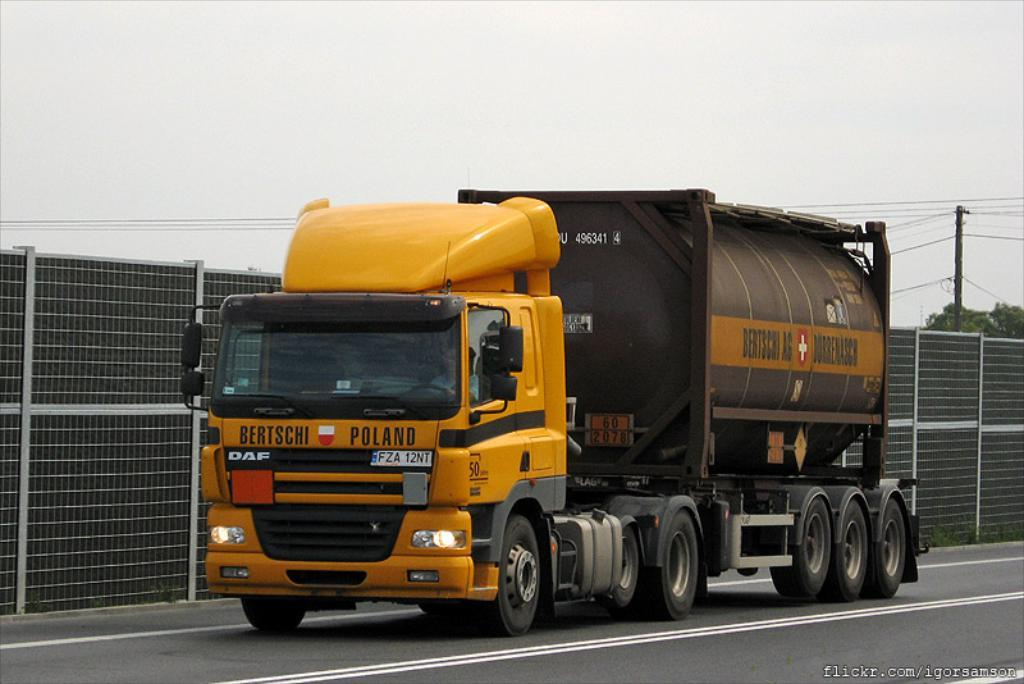What is on the road in the image? There is a vehicle on the road in the image. What can be seen near the road in the image? There is a fence in the image. What else is present in the image besides the fence and vehicle? Wires, trees, a pole, and the sky are visible in the image. What type of bait is being used by the trees in the image? There is no bait present in the image; the trees are not using any bait. Can you describe the kettle that is hanging from the wires in the image? There is no kettle present in the image; only wires are visible. 